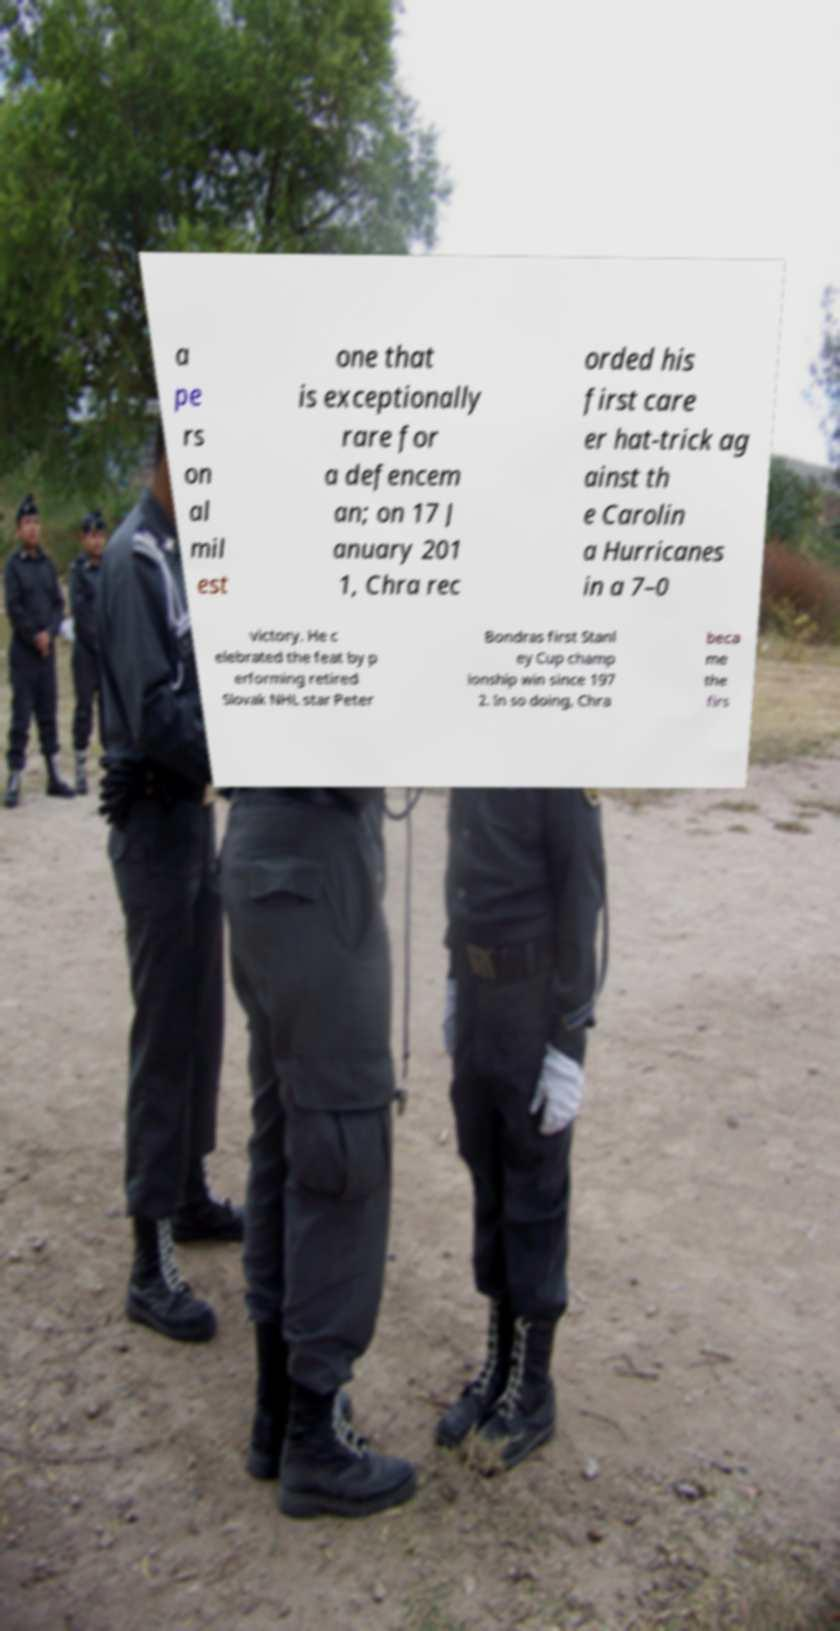There's text embedded in this image that I need extracted. Can you transcribe it verbatim? a pe rs on al mil est one that is exceptionally rare for a defencem an; on 17 J anuary 201 1, Chra rec orded his first care er hat-trick ag ainst th e Carolin a Hurricanes in a 7–0 victory. He c elebrated the feat by p erforming retired Slovak NHL star Peter Bondras first Stanl ey Cup champ ionship win since 197 2. In so doing, Chra beca me the firs 